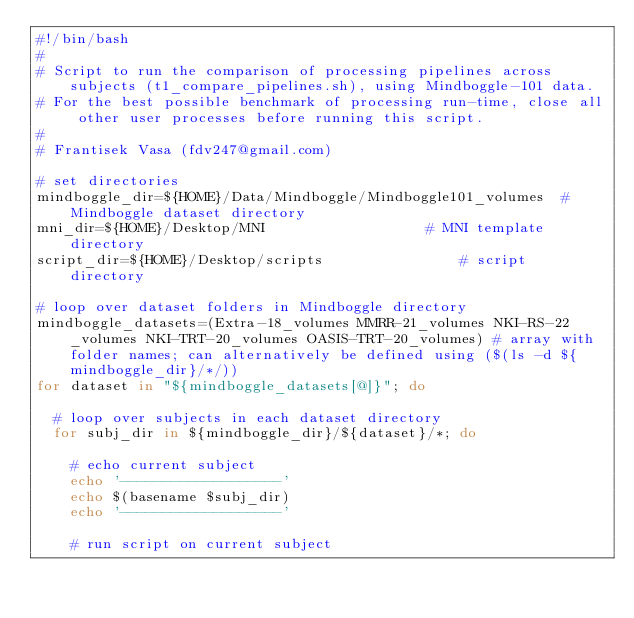Convert code to text. <code><loc_0><loc_0><loc_500><loc_500><_Bash_>#!/bin/bash
#
# Script to run the comparison of processing pipelines across subjects (t1_compare_pipelines.sh), using Mindboggle-101 data.
# For the best possible benchmark of processing run-time, close all other user processes before running this script.
#
# Frantisek Vasa (fdv247@gmail.com)

# set directories
mindboggle_dir=${HOME}/Data/Mindboggle/Mindboggle101_volumes 	# Mindboggle dataset directory
mni_dir=${HOME}/Desktop/MNI										# MNI template directory
script_dir=${HOME}/Desktop/scripts 								# script directory

# loop over dataset folders in Mindboggle directory
mindboggle_datasets=(Extra-18_volumes MMRR-21_volumes NKI-RS-22_volumes NKI-TRT-20_volumes OASIS-TRT-20_volumes) # array with folder names; can alternatively be defined using ($(ls -d ${mindboggle_dir}/*/))
for dataset in "${mindboggle_datasets[@]}"; do

	# loop over subjects in each dataset directory
	for subj_dir in ${mindboggle_dir}/${dataset}/*; do

		# echo current subject
		echo '-------------------'
		echo $(basename $subj_dir)
		echo '-------------------'

		# run script on current subject</code> 